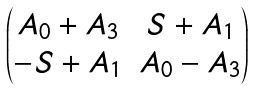<formula> <loc_0><loc_0><loc_500><loc_500>\begin{pmatrix} A _ { 0 } + A _ { 3 } & S + A _ { 1 } \\ - S + A _ { 1 } & A _ { 0 } - A _ { 3 } \end{pmatrix}</formula> 